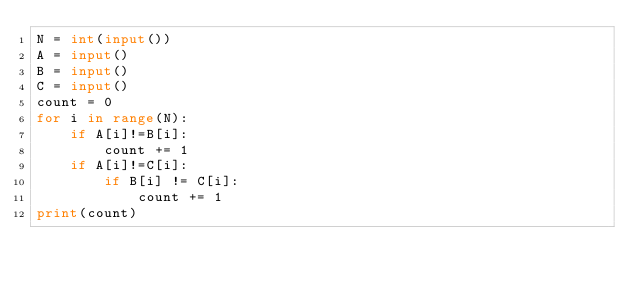Convert code to text. <code><loc_0><loc_0><loc_500><loc_500><_Python_>N = int(input())
A = input()
B = input()
C = input()
count = 0
for i in range(N):
    if A[i]!=B[i]:
        count += 1
    if A[i]!=C[i]:
        if B[i] != C[i]:
            count += 1
print(count)</code> 